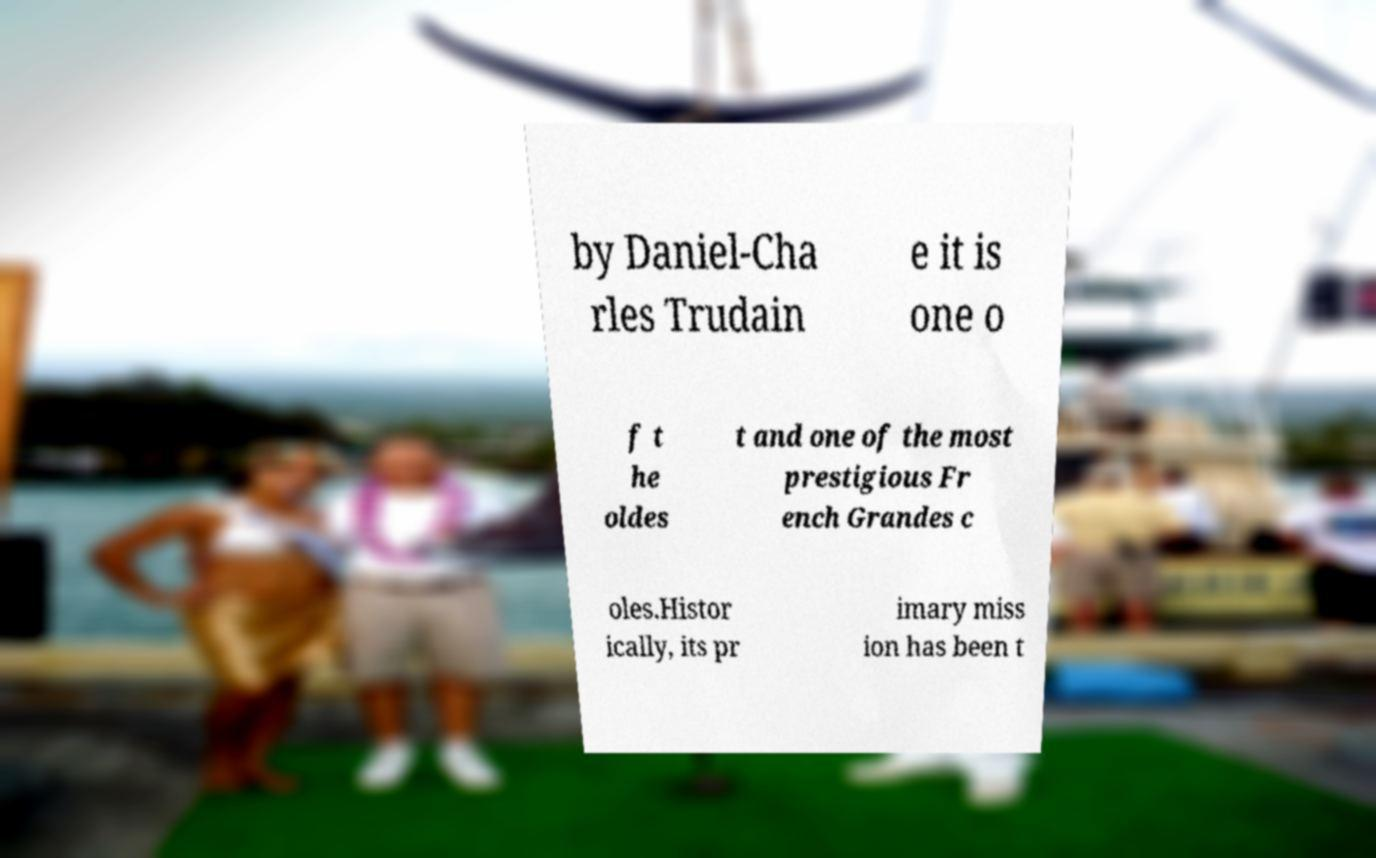I need the written content from this picture converted into text. Can you do that? by Daniel-Cha rles Trudain e it is one o f t he oldes t and one of the most prestigious Fr ench Grandes c oles.Histor ically, its pr imary miss ion has been t 